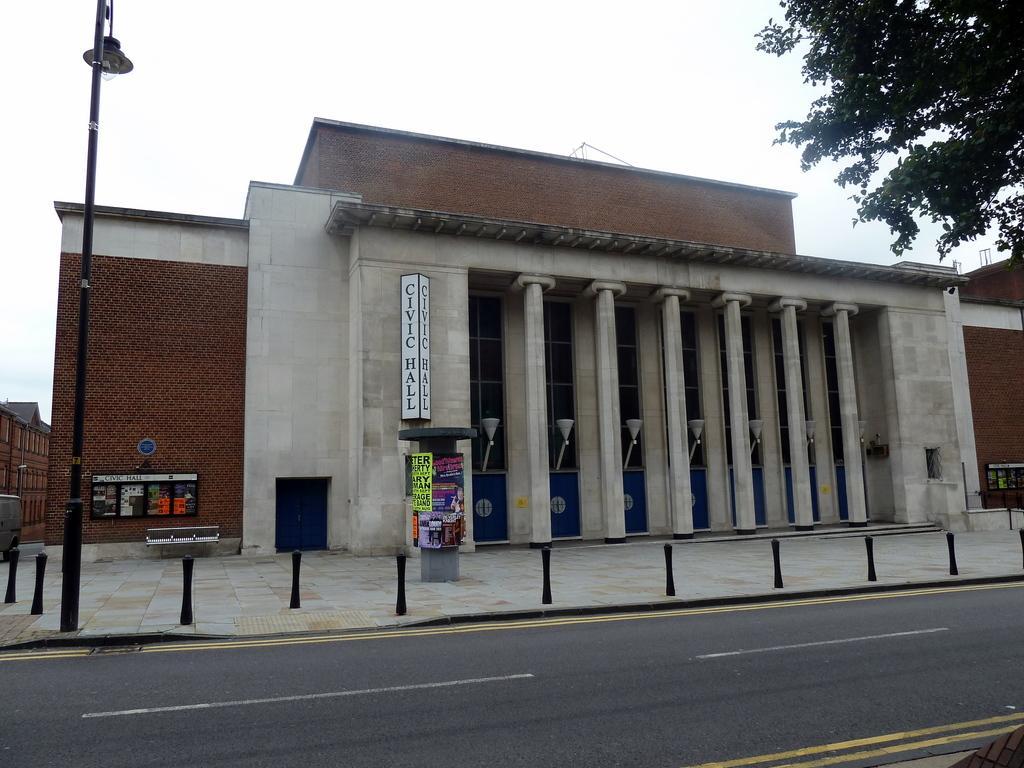Please provide a concise description of this image. In this image, I can see a building with the boards, pillars and lights. In front of a building, I can see the road and lane poles. At the top right side of the image, there is a tree. On the left side of the image, I can see a light pole, vehicle and a building. In the background, there is the sky. 